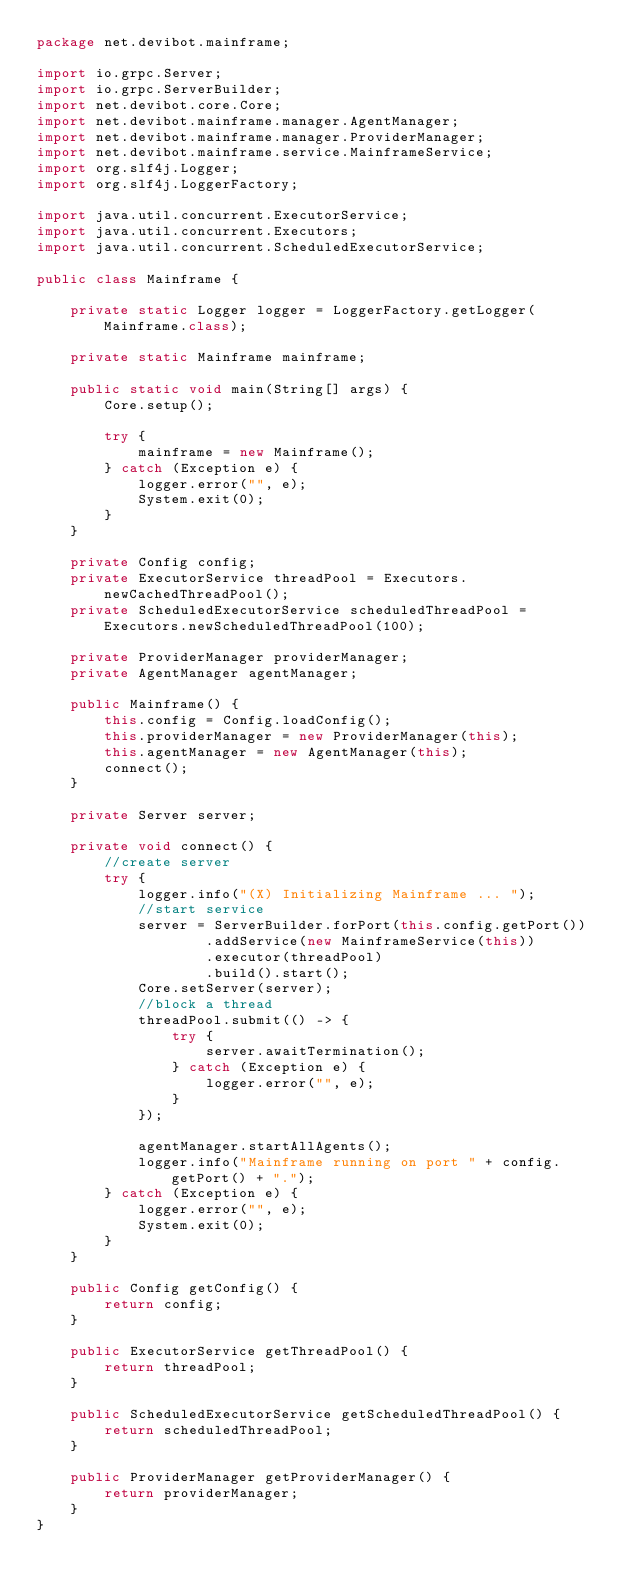<code> <loc_0><loc_0><loc_500><loc_500><_Java_>package net.devibot.mainframe;

import io.grpc.Server;
import io.grpc.ServerBuilder;
import net.devibot.core.Core;
import net.devibot.mainframe.manager.AgentManager;
import net.devibot.mainframe.manager.ProviderManager;
import net.devibot.mainframe.service.MainframeService;
import org.slf4j.Logger;
import org.slf4j.LoggerFactory;

import java.util.concurrent.ExecutorService;
import java.util.concurrent.Executors;
import java.util.concurrent.ScheduledExecutorService;

public class Mainframe {

    private static Logger logger = LoggerFactory.getLogger(Mainframe.class);

    private static Mainframe mainframe;

    public static void main(String[] args) {
        Core.setup();

        try {
            mainframe = new Mainframe();
        } catch (Exception e) {
            logger.error("", e);
            System.exit(0);
        }
    }

    private Config config;
    private ExecutorService threadPool = Executors.newCachedThreadPool();
    private ScheduledExecutorService scheduledThreadPool = Executors.newScheduledThreadPool(100);

    private ProviderManager providerManager;
    private AgentManager agentManager;

    public Mainframe() {
        this.config = Config.loadConfig();
        this.providerManager = new ProviderManager(this);
        this.agentManager = new AgentManager(this);
        connect();
    }

    private Server server;

    private void connect() {
        //create server
        try {
            logger.info("(X) Initializing Mainframe ... ");
            //start service
            server = ServerBuilder.forPort(this.config.getPort())
                    .addService(new MainframeService(this))
                    .executor(threadPool)
                    .build().start();
            Core.setServer(server);
            //block a thread
            threadPool.submit(() -> {
                try {
                    server.awaitTermination();
                } catch (Exception e) {
                    logger.error("", e);
                }
            });

            agentManager.startAllAgents();
            logger.info("Mainframe running on port " + config.getPort() + ".");
        } catch (Exception e) {
            logger.error("", e);
            System.exit(0);
        }
    }

    public Config getConfig() {
        return config;
    }

    public ExecutorService getThreadPool() {
        return threadPool;
    }

    public ScheduledExecutorService getScheduledThreadPool() {
        return scheduledThreadPool;
    }

    public ProviderManager getProviderManager() {
        return providerManager;
    }
}
</code> 